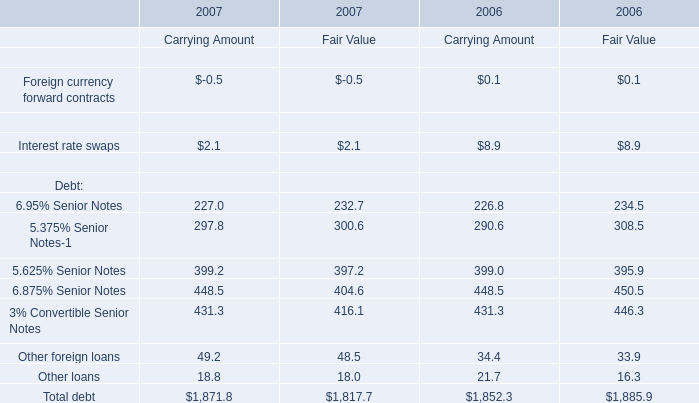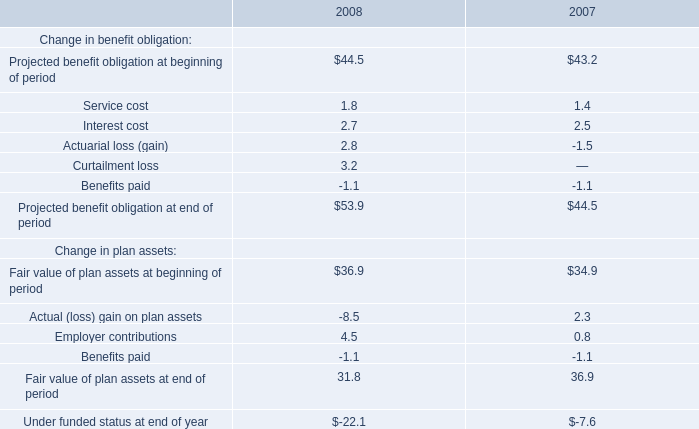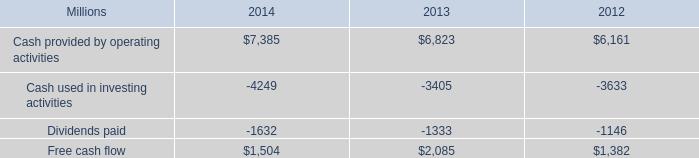What's the growth rate of 6.95% Senior Notes for Carrying Amount in 2007? 
Computations: ((227 - 226.8) / 226.8)
Answer: 0.00088. 